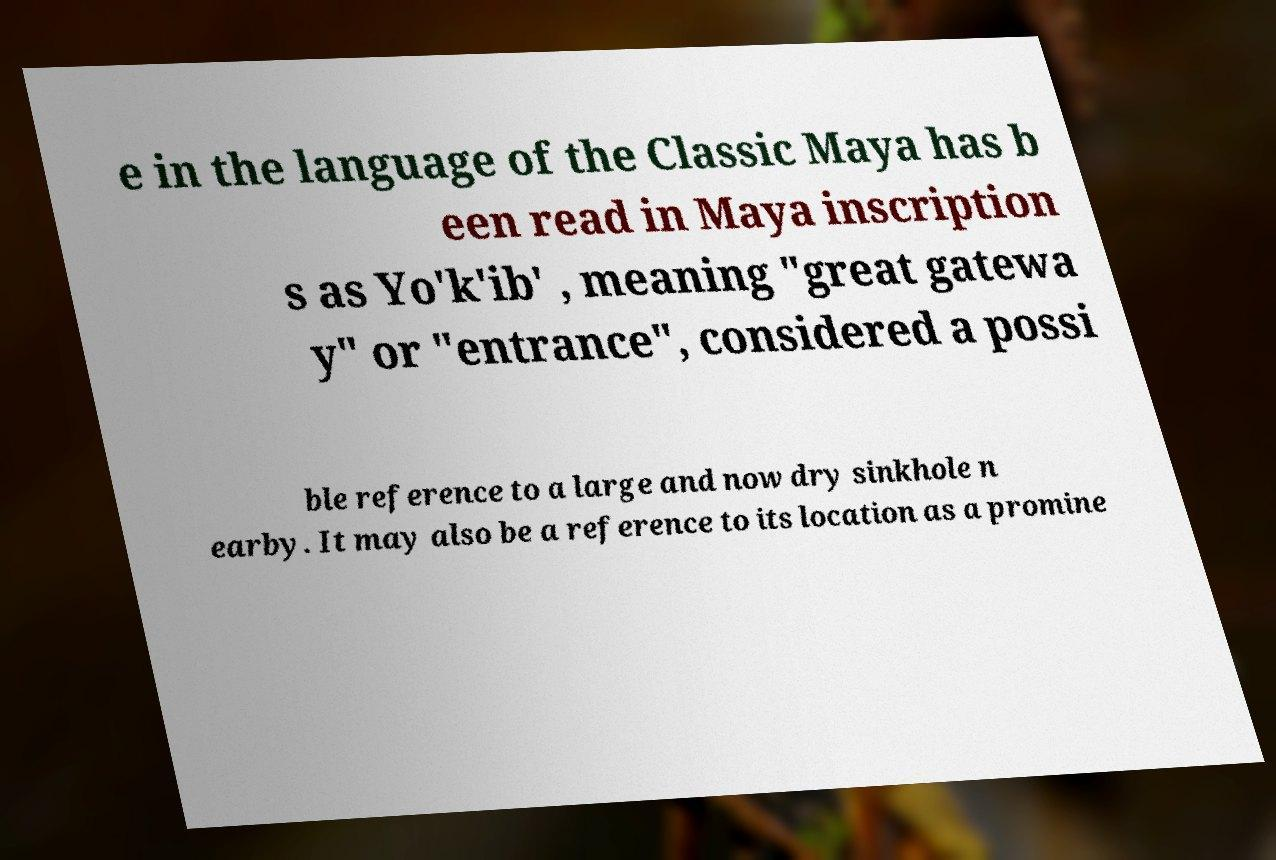Can you accurately transcribe the text from the provided image for me? e in the language of the Classic Maya has b een read in Maya inscription s as Yo'k'ib' , meaning "great gatewa y" or "entrance", considered a possi ble reference to a large and now dry sinkhole n earby. It may also be a reference to its location as a promine 